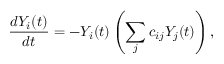<formula> <loc_0><loc_0><loc_500><loc_500>\frac { d Y _ { i } ( t ) } { d t } = - Y _ { i } ( t ) \left ( \sum _ { j } c _ { i j } Y _ { j } ( t ) \right ) ,</formula> 